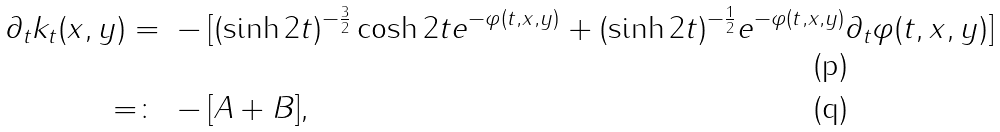<formula> <loc_0><loc_0><loc_500><loc_500>\partial _ { t } k _ { t } ( x , y ) = & \ - [ ( \sinh 2 t ) ^ { - \frac { 3 } { 2 } } \cosh 2 t e ^ { - \varphi ( t , x , y ) } + ( \sinh 2 t ) ^ { - \frac { 1 } { 2 } } e ^ { - \varphi ( t , x , y ) } \partial _ { t } \varphi ( t , x , y ) ] \\ = \colon & \ - [ A + B ] ,</formula> 